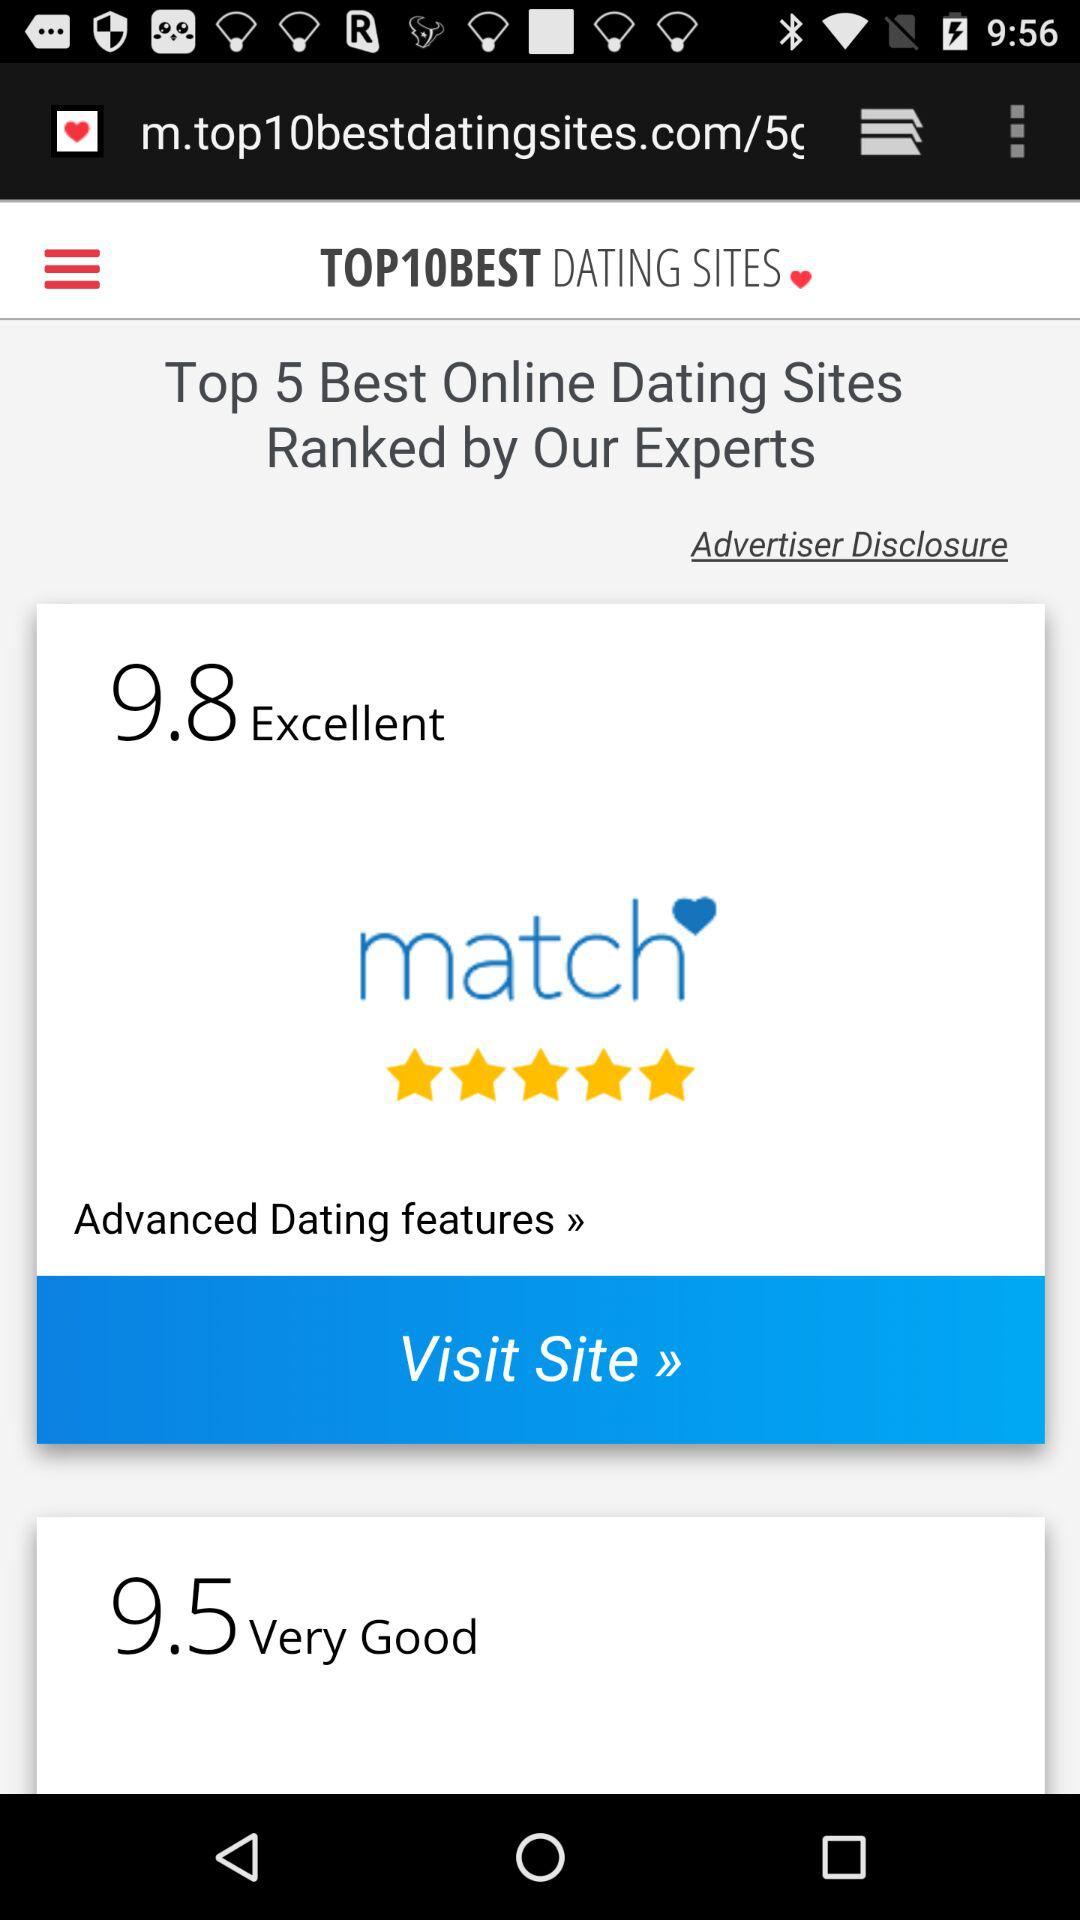What is the star rating of "match" dating site? The rating is 5 stars. 